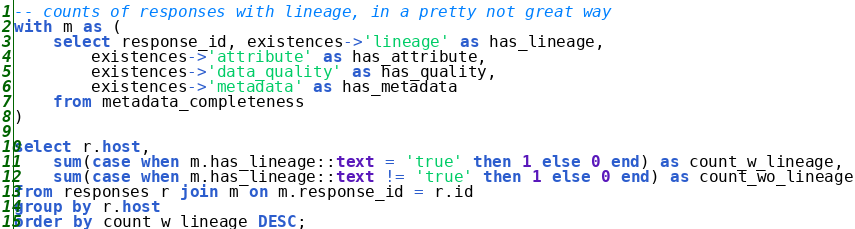Convert code to text. <code><loc_0><loc_0><loc_500><loc_500><_SQL_>-- counts of responses with lineage, in a pretty not great way
with m as (
    select response_id, existences->'lineage' as has_lineage,
        existences->'attribute' as has_attribute,
        existences->'data_quality' as has_quality,
        existences->'metadata' as has_metadata
    from metadata_completeness
)

select r.host,
    sum(case when m.has_lineage::text = 'true' then 1 else 0 end) as count_w_lineage,
    sum(case when m.has_lineage::text != 'true' then 1 else 0 end) as count_wo_lineage
from responses r join m on m.response_id = r.id
group by r.host
order by count_w_lineage DESC;</code> 